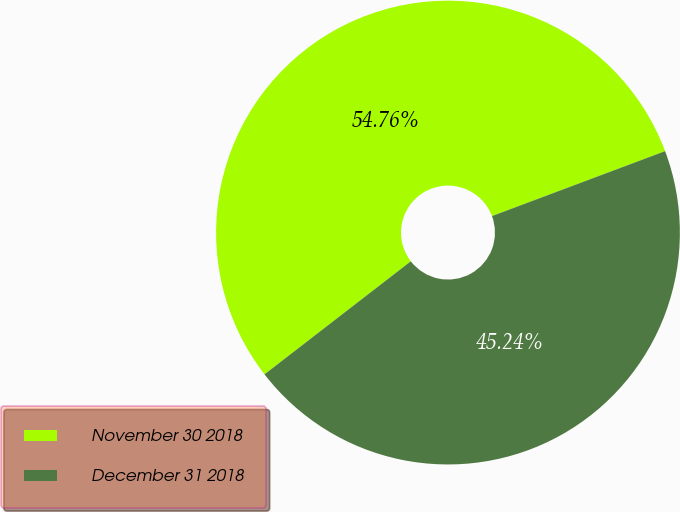<chart> <loc_0><loc_0><loc_500><loc_500><pie_chart><fcel>November 30 2018<fcel>December 31 2018<nl><fcel>54.76%<fcel>45.24%<nl></chart> 